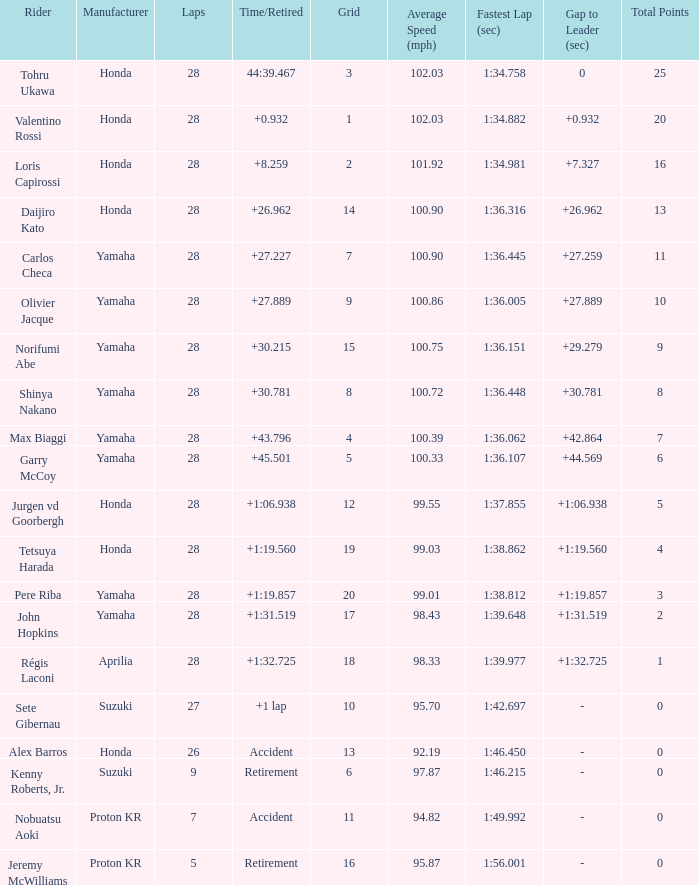Who manufactured grid 11? Proton KR. 